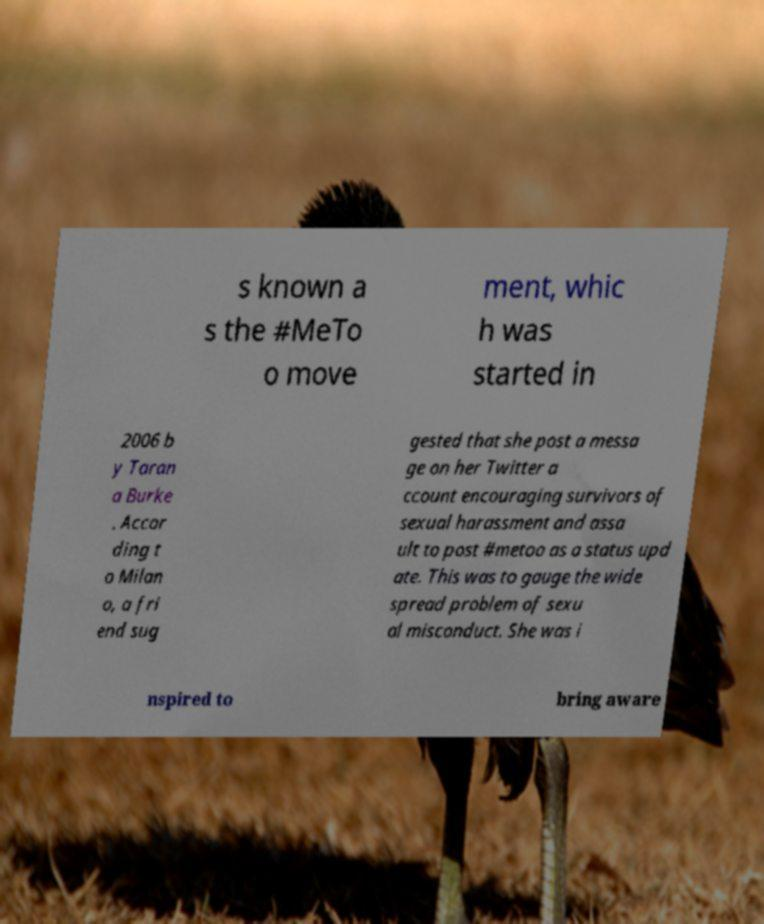I need the written content from this picture converted into text. Can you do that? s known a s the #MeTo o move ment, whic h was started in 2006 b y Taran a Burke . Accor ding t o Milan o, a fri end sug gested that she post a messa ge on her Twitter a ccount encouraging survivors of sexual harassment and assa ult to post #metoo as a status upd ate. This was to gauge the wide spread problem of sexu al misconduct. She was i nspired to bring aware 